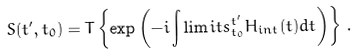<formula> <loc_0><loc_0><loc_500><loc_500>S ( t ^ { \prime } , t _ { 0 } ) = T \left \{ { \exp \left ( { - i \int \lim i t s _ { t _ { 0 } } ^ { t ^ { \prime } } { H _ { i n t } ( t ) d t } } \right ) } \right \} \, .</formula> 